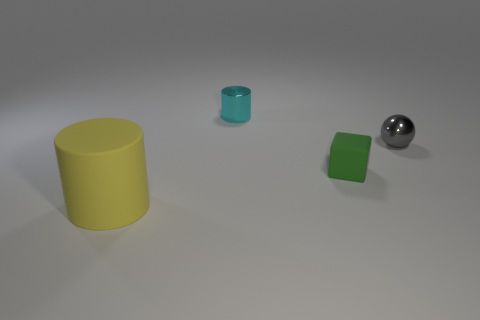Are there any matte things left of the matte object on the right side of the cylinder that is right of the big yellow rubber thing?
Your answer should be compact. Yes. Are there any yellow matte cylinders on the right side of the large cylinder?
Provide a succinct answer. No. What number of large things have the same color as the tiny cylinder?
Keep it short and to the point. 0. What is the size of the other green object that is the same material as the large object?
Give a very brief answer. Small. What size is the cylinder that is left of the tiny cyan shiny object that is on the left side of the ball in front of the tiny cyan metallic object?
Make the answer very short. Large. What is the size of the matte object that is in front of the small rubber cube?
Ensure brevity in your answer.  Large. How many gray things are tiny matte cylinders or shiny objects?
Ensure brevity in your answer.  1. Is there a gray object of the same size as the cyan object?
Provide a succinct answer. Yes. There is a sphere that is the same size as the cyan metallic cylinder; what material is it?
Keep it short and to the point. Metal. Does the cylinder that is to the right of the matte cylinder have the same size as the rubber object that is behind the rubber cylinder?
Offer a terse response. Yes. 